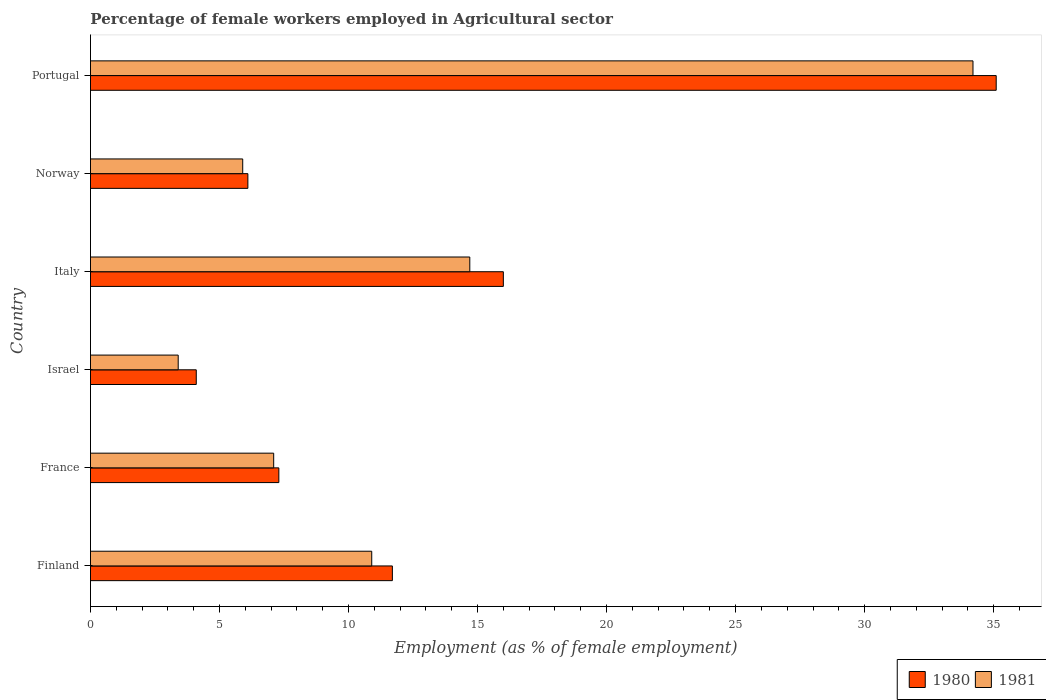Are the number of bars per tick equal to the number of legend labels?
Your answer should be compact. Yes. What is the label of the 1st group of bars from the top?
Your answer should be very brief. Portugal. What is the percentage of females employed in Agricultural sector in 1980 in Italy?
Give a very brief answer. 16. Across all countries, what is the maximum percentage of females employed in Agricultural sector in 1981?
Provide a succinct answer. 34.2. Across all countries, what is the minimum percentage of females employed in Agricultural sector in 1980?
Your answer should be very brief. 4.1. In which country was the percentage of females employed in Agricultural sector in 1980 minimum?
Make the answer very short. Israel. What is the total percentage of females employed in Agricultural sector in 1980 in the graph?
Provide a succinct answer. 80.3. What is the difference between the percentage of females employed in Agricultural sector in 1981 in Norway and that in Portugal?
Offer a terse response. -28.3. What is the difference between the percentage of females employed in Agricultural sector in 1980 in Finland and the percentage of females employed in Agricultural sector in 1981 in Israel?
Make the answer very short. 8.3. What is the average percentage of females employed in Agricultural sector in 1981 per country?
Provide a short and direct response. 12.7. What is the difference between the percentage of females employed in Agricultural sector in 1980 and percentage of females employed in Agricultural sector in 1981 in France?
Your answer should be compact. 0.2. In how many countries, is the percentage of females employed in Agricultural sector in 1980 greater than 21 %?
Offer a terse response. 1. What is the ratio of the percentage of females employed in Agricultural sector in 1980 in Finland to that in Israel?
Your answer should be very brief. 2.85. Is the percentage of females employed in Agricultural sector in 1980 in Finland less than that in Norway?
Your answer should be compact. No. What is the difference between the highest and the second highest percentage of females employed in Agricultural sector in 1981?
Provide a succinct answer. 19.5. What is the difference between the highest and the lowest percentage of females employed in Agricultural sector in 1981?
Provide a short and direct response. 30.8. Is the sum of the percentage of females employed in Agricultural sector in 1980 in Israel and Norway greater than the maximum percentage of females employed in Agricultural sector in 1981 across all countries?
Make the answer very short. No. What does the 1st bar from the top in Portugal represents?
Offer a very short reply. 1981. How many countries are there in the graph?
Your answer should be compact. 6. What is the difference between two consecutive major ticks on the X-axis?
Keep it short and to the point. 5. Does the graph contain any zero values?
Offer a terse response. No. Does the graph contain grids?
Provide a succinct answer. No. Where does the legend appear in the graph?
Offer a terse response. Bottom right. How many legend labels are there?
Give a very brief answer. 2. What is the title of the graph?
Provide a succinct answer. Percentage of female workers employed in Agricultural sector. What is the label or title of the X-axis?
Provide a short and direct response. Employment (as % of female employment). What is the label or title of the Y-axis?
Offer a very short reply. Country. What is the Employment (as % of female employment) in 1980 in Finland?
Offer a very short reply. 11.7. What is the Employment (as % of female employment) of 1981 in Finland?
Your answer should be very brief. 10.9. What is the Employment (as % of female employment) of 1980 in France?
Offer a very short reply. 7.3. What is the Employment (as % of female employment) in 1981 in France?
Provide a succinct answer. 7.1. What is the Employment (as % of female employment) in 1980 in Israel?
Offer a very short reply. 4.1. What is the Employment (as % of female employment) in 1981 in Israel?
Offer a terse response. 3.4. What is the Employment (as % of female employment) of 1981 in Italy?
Offer a terse response. 14.7. What is the Employment (as % of female employment) in 1980 in Norway?
Provide a short and direct response. 6.1. What is the Employment (as % of female employment) of 1981 in Norway?
Your answer should be compact. 5.9. What is the Employment (as % of female employment) of 1980 in Portugal?
Keep it short and to the point. 35.1. What is the Employment (as % of female employment) of 1981 in Portugal?
Make the answer very short. 34.2. Across all countries, what is the maximum Employment (as % of female employment) of 1980?
Your answer should be very brief. 35.1. Across all countries, what is the maximum Employment (as % of female employment) in 1981?
Give a very brief answer. 34.2. Across all countries, what is the minimum Employment (as % of female employment) of 1980?
Ensure brevity in your answer.  4.1. Across all countries, what is the minimum Employment (as % of female employment) of 1981?
Your response must be concise. 3.4. What is the total Employment (as % of female employment) in 1980 in the graph?
Ensure brevity in your answer.  80.3. What is the total Employment (as % of female employment) in 1981 in the graph?
Ensure brevity in your answer.  76.2. What is the difference between the Employment (as % of female employment) of 1981 in Finland and that in France?
Give a very brief answer. 3.8. What is the difference between the Employment (as % of female employment) in 1980 in Finland and that in Italy?
Your response must be concise. -4.3. What is the difference between the Employment (as % of female employment) in 1980 in Finland and that in Portugal?
Offer a terse response. -23.4. What is the difference between the Employment (as % of female employment) in 1981 in Finland and that in Portugal?
Your answer should be very brief. -23.3. What is the difference between the Employment (as % of female employment) in 1981 in France and that in Norway?
Ensure brevity in your answer.  1.2. What is the difference between the Employment (as % of female employment) in 1980 in France and that in Portugal?
Your answer should be very brief. -27.8. What is the difference between the Employment (as % of female employment) in 1981 in France and that in Portugal?
Your answer should be very brief. -27.1. What is the difference between the Employment (as % of female employment) in 1980 in Israel and that in Norway?
Provide a succinct answer. -2. What is the difference between the Employment (as % of female employment) in 1980 in Israel and that in Portugal?
Your answer should be very brief. -31. What is the difference between the Employment (as % of female employment) of 1981 in Israel and that in Portugal?
Keep it short and to the point. -30.8. What is the difference between the Employment (as % of female employment) of 1981 in Italy and that in Norway?
Provide a short and direct response. 8.8. What is the difference between the Employment (as % of female employment) in 1980 in Italy and that in Portugal?
Your response must be concise. -19.1. What is the difference between the Employment (as % of female employment) of 1981 in Italy and that in Portugal?
Your response must be concise. -19.5. What is the difference between the Employment (as % of female employment) of 1980 in Norway and that in Portugal?
Offer a very short reply. -29. What is the difference between the Employment (as % of female employment) in 1981 in Norway and that in Portugal?
Offer a very short reply. -28.3. What is the difference between the Employment (as % of female employment) of 1980 in Finland and the Employment (as % of female employment) of 1981 in France?
Your answer should be compact. 4.6. What is the difference between the Employment (as % of female employment) of 1980 in Finland and the Employment (as % of female employment) of 1981 in Israel?
Your response must be concise. 8.3. What is the difference between the Employment (as % of female employment) in 1980 in Finland and the Employment (as % of female employment) in 1981 in Italy?
Your response must be concise. -3. What is the difference between the Employment (as % of female employment) of 1980 in Finland and the Employment (as % of female employment) of 1981 in Norway?
Offer a terse response. 5.8. What is the difference between the Employment (as % of female employment) of 1980 in Finland and the Employment (as % of female employment) of 1981 in Portugal?
Offer a terse response. -22.5. What is the difference between the Employment (as % of female employment) in 1980 in France and the Employment (as % of female employment) in 1981 in Italy?
Ensure brevity in your answer.  -7.4. What is the difference between the Employment (as % of female employment) of 1980 in France and the Employment (as % of female employment) of 1981 in Portugal?
Offer a terse response. -26.9. What is the difference between the Employment (as % of female employment) in 1980 in Israel and the Employment (as % of female employment) in 1981 in Italy?
Your answer should be compact. -10.6. What is the difference between the Employment (as % of female employment) of 1980 in Israel and the Employment (as % of female employment) of 1981 in Portugal?
Make the answer very short. -30.1. What is the difference between the Employment (as % of female employment) of 1980 in Italy and the Employment (as % of female employment) of 1981 in Norway?
Keep it short and to the point. 10.1. What is the difference between the Employment (as % of female employment) of 1980 in Italy and the Employment (as % of female employment) of 1981 in Portugal?
Offer a very short reply. -18.2. What is the difference between the Employment (as % of female employment) of 1980 in Norway and the Employment (as % of female employment) of 1981 in Portugal?
Provide a succinct answer. -28.1. What is the average Employment (as % of female employment) in 1980 per country?
Offer a terse response. 13.38. What is the difference between the Employment (as % of female employment) of 1980 and Employment (as % of female employment) of 1981 in Finland?
Keep it short and to the point. 0.8. What is the difference between the Employment (as % of female employment) in 1980 and Employment (as % of female employment) in 1981 in Portugal?
Your answer should be compact. 0.9. What is the ratio of the Employment (as % of female employment) in 1980 in Finland to that in France?
Provide a succinct answer. 1.6. What is the ratio of the Employment (as % of female employment) of 1981 in Finland to that in France?
Give a very brief answer. 1.54. What is the ratio of the Employment (as % of female employment) in 1980 in Finland to that in Israel?
Your answer should be very brief. 2.85. What is the ratio of the Employment (as % of female employment) in 1981 in Finland to that in Israel?
Provide a short and direct response. 3.21. What is the ratio of the Employment (as % of female employment) of 1980 in Finland to that in Italy?
Your answer should be very brief. 0.73. What is the ratio of the Employment (as % of female employment) of 1981 in Finland to that in Italy?
Give a very brief answer. 0.74. What is the ratio of the Employment (as % of female employment) of 1980 in Finland to that in Norway?
Offer a terse response. 1.92. What is the ratio of the Employment (as % of female employment) of 1981 in Finland to that in Norway?
Your answer should be compact. 1.85. What is the ratio of the Employment (as % of female employment) in 1980 in Finland to that in Portugal?
Your answer should be very brief. 0.33. What is the ratio of the Employment (as % of female employment) in 1981 in Finland to that in Portugal?
Ensure brevity in your answer.  0.32. What is the ratio of the Employment (as % of female employment) in 1980 in France to that in Israel?
Provide a succinct answer. 1.78. What is the ratio of the Employment (as % of female employment) of 1981 in France to that in Israel?
Provide a succinct answer. 2.09. What is the ratio of the Employment (as % of female employment) of 1980 in France to that in Italy?
Ensure brevity in your answer.  0.46. What is the ratio of the Employment (as % of female employment) of 1981 in France to that in Italy?
Offer a terse response. 0.48. What is the ratio of the Employment (as % of female employment) of 1980 in France to that in Norway?
Give a very brief answer. 1.2. What is the ratio of the Employment (as % of female employment) of 1981 in France to that in Norway?
Ensure brevity in your answer.  1.2. What is the ratio of the Employment (as % of female employment) of 1980 in France to that in Portugal?
Make the answer very short. 0.21. What is the ratio of the Employment (as % of female employment) of 1981 in France to that in Portugal?
Keep it short and to the point. 0.21. What is the ratio of the Employment (as % of female employment) in 1980 in Israel to that in Italy?
Give a very brief answer. 0.26. What is the ratio of the Employment (as % of female employment) of 1981 in Israel to that in Italy?
Keep it short and to the point. 0.23. What is the ratio of the Employment (as % of female employment) of 1980 in Israel to that in Norway?
Your answer should be very brief. 0.67. What is the ratio of the Employment (as % of female employment) of 1981 in Israel to that in Norway?
Offer a very short reply. 0.58. What is the ratio of the Employment (as % of female employment) in 1980 in Israel to that in Portugal?
Your answer should be compact. 0.12. What is the ratio of the Employment (as % of female employment) in 1981 in Israel to that in Portugal?
Offer a very short reply. 0.1. What is the ratio of the Employment (as % of female employment) in 1980 in Italy to that in Norway?
Make the answer very short. 2.62. What is the ratio of the Employment (as % of female employment) of 1981 in Italy to that in Norway?
Provide a short and direct response. 2.49. What is the ratio of the Employment (as % of female employment) in 1980 in Italy to that in Portugal?
Offer a very short reply. 0.46. What is the ratio of the Employment (as % of female employment) of 1981 in Italy to that in Portugal?
Offer a very short reply. 0.43. What is the ratio of the Employment (as % of female employment) in 1980 in Norway to that in Portugal?
Keep it short and to the point. 0.17. What is the ratio of the Employment (as % of female employment) in 1981 in Norway to that in Portugal?
Provide a short and direct response. 0.17. What is the difference between the highest and the lowest Employment (as % of female employment) in 1980?
Give a very brief answer. 31. What is the difference between the highest and the lowest Employment (as % of female employment) in 1981?
Provide a short and direct response. 30.8. 